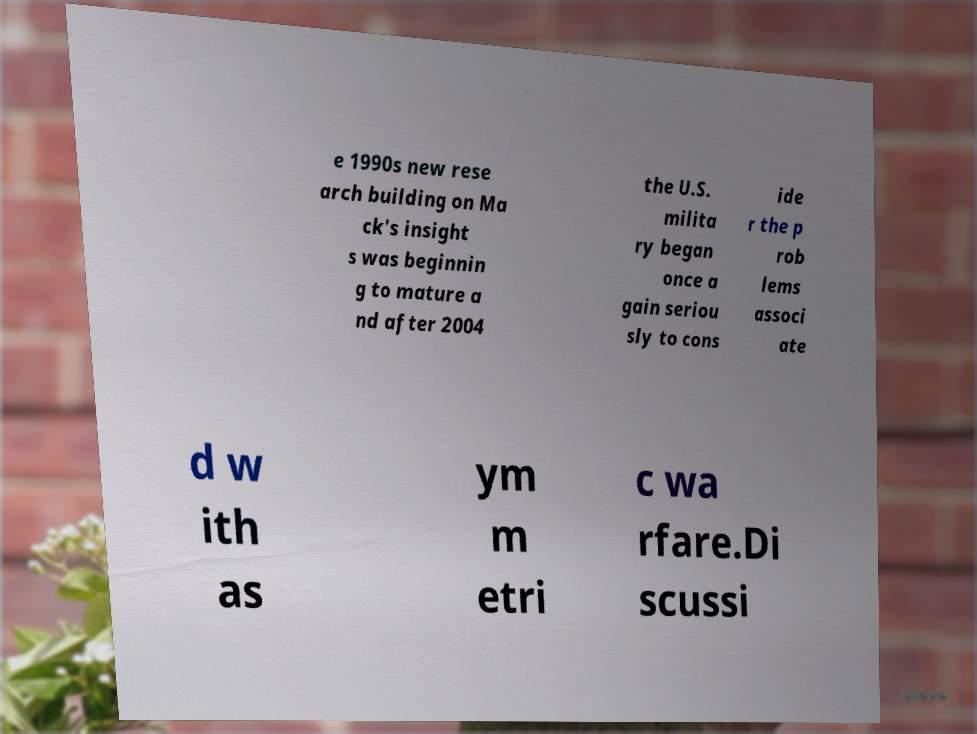There's text embedded in this image that I need extracted. Can you transcribe it verbatim? e 1990s new rese arch building on Ma ck's insight s was beginnin g to mature a nd after 2004 the U.S. milita ry began once a gain seriou sly to cons ide r the p rob lems associ ate d w ith as ym m etri c wa rfare.Di scussi 